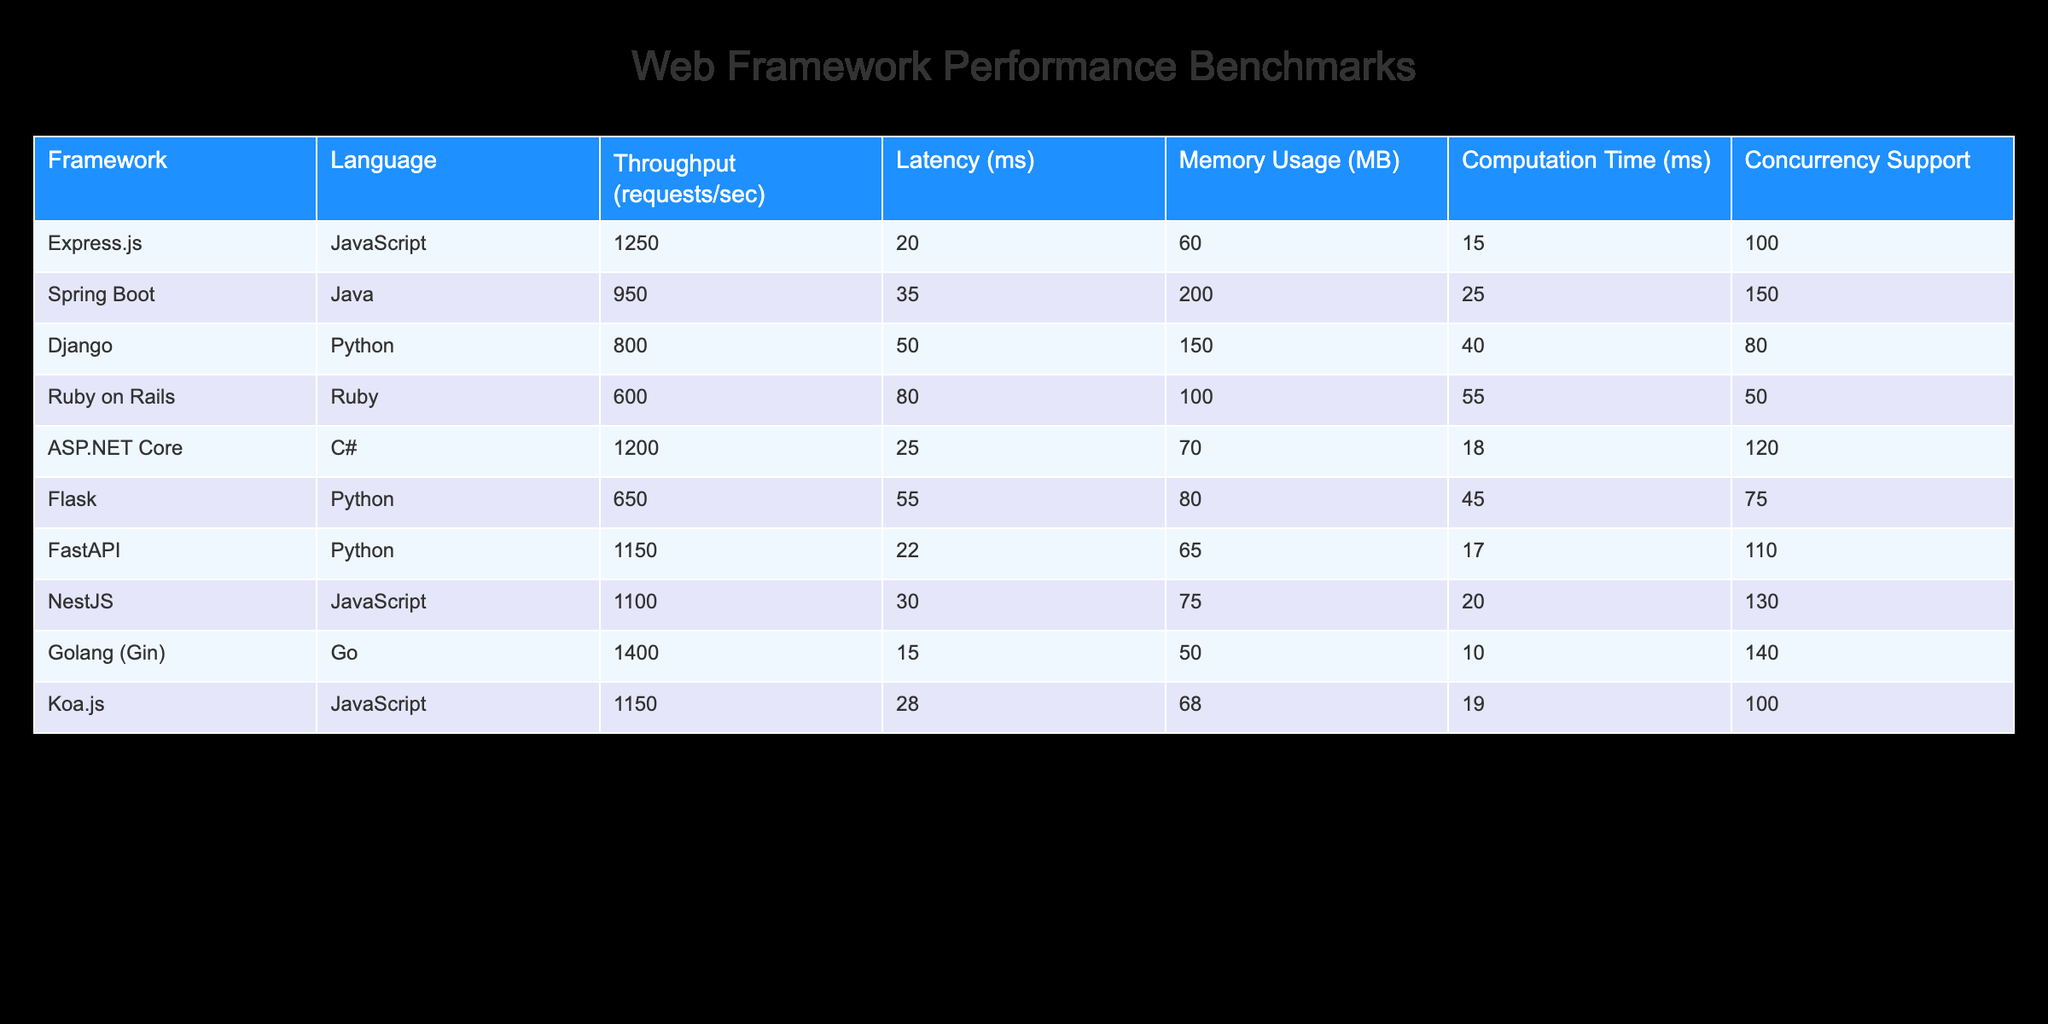What is the framework with the highest throughput? The throughput values in the table show that Golang (Gin) has the highest value at 1400 requests per second.
Answer: Golang (Gin) What is the average latency of Python frameworks listed in the table? The latency values for Python frameworks are 50 ms for Django and 55 ms for Flask, totaling 105 ms. The average is 105/2 = 52.5 ms.
Answer: 52.5 Is Express.js faster than Spring Boot in terms of throughput? The throughput of Express.js is 1250 requests per second, while that of Spring Boot is 950 requests per second. Since 1250 is greater than 950, Express.js is indeed faster.
Answer: Yes Which framework has the highest memory usage? Comparing the memory usage values, Spring Boot has the highest usage at 200 MB.
Answer: Spring Boot What is the difference in throughput between ASP.NET Core and FastAPI? The throughput for ASP.NET Core is 1200 requests per second, and for FastAPI, it is 1150 requests per second. The difference is 1200 - 1150 = 50 requests per second.
Answer: 50 Which programming language generally offers the lowest latency based on the frameworks listed? Among the frameworks, Golang (Gin) has the lowest latency at 15 ms, which reveals that it generally offers the best performance in terms of latency.
Answer: Go How many frameworks support a concurrency of more than 100? The frameworks supporting concurrency greater than 100 are Express.js (100), ASP.NET Core (120), FastAPI (110), NestJS (130), and Golang (Gin) (140), making a total count of 5 frameworks.
Answer: 5 What framework would you recommend for projects prioritizing high throughput and low latency combined? The framework Golang (Gin) offers the best combination with the highest throughput (1400 requests/sec) and lowest latency (15 ms). This ensures optimal performance for projects needing efficiency.
Answer: Golang (Gin) Is it true that Ruby on Rails has a higher computation time than Django? Ruby on Rails has a computation time of 55 ms, while Django's computation time is 40 ms. Therefore, Ruby on Rails has a higher computation time, making the statement true.
Answer: Yes 